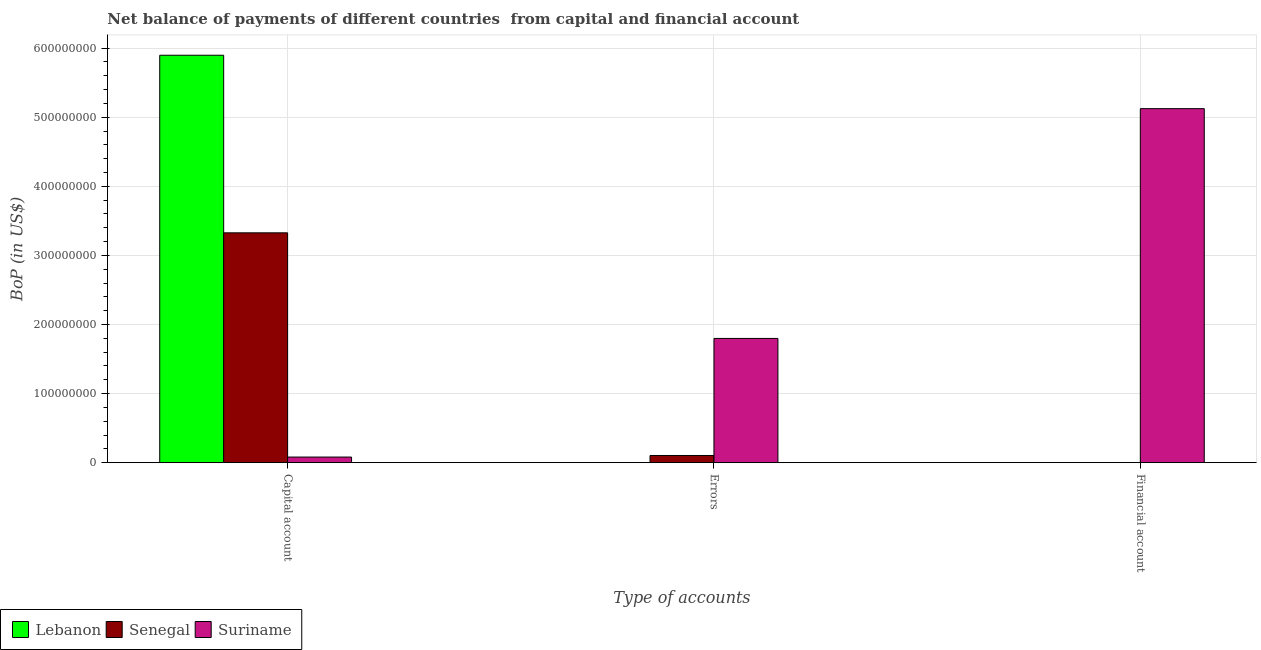How many different coloured bars are there?
Your response must be concise. 3. How many bars are there on the 3rd tick from the left?
Your answer should be very brief. 1. What is the label of the 1st group of bars from the left?
Keep it short and to the point. Capital account. What is the amount of net capital account in Lebanon?
Make the answer very short. 5.90e+08. Across all countries, what is the maximum amount of errors?
Ensure brevity in your answer.  1.80e+08. Across all countries, what is the minimum amount of net capital account?
Your response must be concise. 8.10e+06. In which country was the amount of financial account maximum?
Provide a succinct answer. Suriname. What is the total amount of net capital account in the graph?
Make the answer very short. 9.30e+08. What is the difference between the amount of net capital account in Lebanon and that in Senegal?
Ensure brevity in your answer.  2.57e+08. What is the average amount of financial account per country?
Offer a terse response. 1.71e+08. What is the difference between the amount of net capital account and amount of financial account in Suriname?
Ensure brevity in your answer.  -5.04e+08. What is the ratio of the amount of errors in Suriname to that in Senegal?
Give a very brief answer. 17.37. Is the amount of net capital account in Lebanon less than that in Senegal?
Make the answer very short. No. Is the difference between the amount of net capital account in Suriname and Senegal greater than the difference between the amount of errors in Suriname and Senegal?
Your answer should be very brief. No. What is the difference between the highest and the second highest amount of net capital account?
Keep it short and to the point. 2.57e+08. What is the difference between the highest and the lowest amount of errors?
Make the answer very short. 1.80e+08. In how many countries, is the amount of net capital account greater than the average amount of net capital account taken over all countries?
Offer a terse response. 2. Are all the bars in the graph horizontal?
Your answer should be very brief. No. How many countries are there in the graph?
Offer a terse response. 3. What is the difference between two consecutive major ticks on the Y-axis?
Provide a succinct answer. 1.00e+08. Are the values on the major ticks of Y-axis written in scientific E-notation?
Your answer should be compact. No. Does the graph contain any zero values?
Keep it short and to the point. Yes. Where does the legend appear in the graph?
Give a very brief answer. Bottom left. How many legend labels are there?
Ensure brevity in your answer.  3. How are the legend labels stacked?
Ensure brevity in your answer.  Horizontal. What is the title of the graph?
Your answer should be compact. Net balance of payments of different countries  from capital and financial account. Does "Yemen, Rep." appear as one of the legend labels in the graph?
Offer a very short reply. No. What is the label or title of the X-axis?
Make the answer very short. Type of accounts. What is the label or title of the Y-axis?
Your answer should be very brief. BoP (in US$). What is the BoP (in US$) in Lebanon in Capital account?
Your answer should be compact. 5.90e+08. What is the BoP (in US$) of Senegal in Capital account?
Your answer should be compact. 3.33e+08. What is the BoP (in US$) in Suriname in Capital account?
Keep it short and to the point. 8.10e+06. What is the BoP (in US$) in Senegal in Errors?
Your response must be concise. 1.03e+07. What is the BoP (in US$) of Suriname in Errors?
Your answer should be compact. 1.80e+08. What is the BoP (in US$) in Lebanon in Financial account?
Your response must be concise. 0. What is the BoP (in US$) of Senegal in Financial account?
Give a very brief answer. 0. What is the BoP (in US$) in Suriname in Financial account?
Ensure brevity in your answer.  5.12e+08. Across all Type of accounts, what is the maximum BoP (in US$) in Lebanon?
Make the answer very short. 5.90e+08. Across all Type of accounts, what is the maximum BoP (in US$) of Senegal?
Offer a very short reply. 3.33e+08. Across all Type of accounts, what is the maximum BoP (in US$) in Suriname?
Ensure brevity in your answer.  5.12e+08. Across all Type of accounts, what is the minimum BoP (in US$) of Lebanon?
Your answer should be compact. 0. Across all Type of accounts, what is the minimum BoP (in US$) in Senegal?
Make the answer very short. 0. Across all Type of accounts, what is the minimum BoP (in US$) of Suriname?
Make the answer very short. 8.10e+06. What is the total BoP (in US$) of Lebanon in the graph?
Your answer should be very brief. 5.90e+08. What is the total BoP (in US$) in Senegal in the graph?
Ensure brevity in your answer.  3.43e+08. What is the total BoP (in US$) of Suriname in the graph?
Give a very brief answer. 7.00e+08. What is the difference between the BoP (in US$) in Senegal in Capital account and that in Errors?
Offer a terse response. 3.22e+08. What is the difference between the BoP (in US$) in Suriname in Capital account and that in Errors?
Provide a succinct answer. -1.72e+08. What is the difference between the BoP (in US$) of Suriname in Capital account and that in Financial account?
Provide a short and direct response. -5.04e+08. What is the difference between the BoP (in US$) of Suriname in Errors and that in Financial account?
Keep it short and to the point. -3.33e+08. What is the difference between the BoP (in US$) of Lebanon in Capital account and the BoP (in US$) of Senegal in Errors?
Offer a very short reply. 5.79e+08. What is the difference between the BoP (in US$) in Lebanon in Capital account and the BoP (in US$) in Suriname in Errors?
Make the answer very short. 4.10e+08. What is the difference between the BoP (in US$) in Senegal in Capital account and the BoP (in US$) in Suriname in Errors?
Ensure brevity in your answer.  1.53e+08. What is the difference between the BoP (in US$) of Lebanon in Capital account and the BoP (in US$) of Suriname in Financial account?
Provide a short and direct response. 7.73e+07. What is the difference between the BoP (in US$) in Senegal in Capital account and the BoP (in US$) in Suriname in Financial account?
Offer a very short reply. -1.80e+08. What is the difference between the BoP (in US$) of Senegal in Errors and the BoP (in US$) of Suriname in Financial account?
Your response must be concise. -5.02e+08. What is the average BoP (in US$) of Lebanon per Type of accounts?
Provide a short and direct response. 1.97e+08. What is the average BoP (in US$) in Senegal per Type of accounts?
Give a very brief answer. 1.14e+08. What is the average BoP (in US$) of Suriname per Type of accounts?
Offer a very short reply. 2.33e+08. What is the difference between the BoP (in US$) in Lebanon and BoP (in US$) in Senegal in Capital account?
Provide a short and direct response. 2.57e+08. What is the difference between the BoP (in US$) in Lebanon and BoP (in US$) in Suriname in Capital account?
Offer a terse response. 5.82e+08. What is the difference between the BoP (in US$) in Senegal and BoP (in US$) in Suriname in Capital account?
Give a very brief answer. 3.25e+08. What is the difference between the BoP (in US$) of Senegal and BoP (in US$) of Suriname in Errors?
Give a very brief answer. -1.69e+08. What is the ratio of the BoP (in US$) in Senegal in Capital account to that in Errors?
Offer a terse response. 32.14. What is the ratio of the BoP (in US$) in Suriname in Capital account to that in Errors?
Provide a short and direct response. 0.05. What is the ratio of the BoP (in US$) in Suriname in Capital account to that in Financial account?
Provide a succinct answer. 0.02. What is the ratio of the BoP (in US$) of Suriname in Errors to that in Financial account?
Your answer should be very brief. 0.35. What is the difference between the highest and the second highest BoP (in US$) in Suriname?
Provide a short and direct response. 3.33e+08. What is the difference between the highest and the lowest BoP (in US$) of Lebanon?
Make the answer very short. 5.90e+08. What is the difference between the highest and the lowest BoP (in US$) of Senegal?
Offer a terse response. 3.33e+08. What is the difference between the highest and the lowest BoP (in US$) in Suriname?
Offer a very short reply. 5.04e+08. 